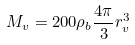Convert formula to latex. <formula><loc_0><loc_0><loc_500><loc_500>M _ { v } = 2 0 0 \rho _ { b } \frac { 4 \pi } { 3 } r _ { v } ^ { 3 }</formula> 